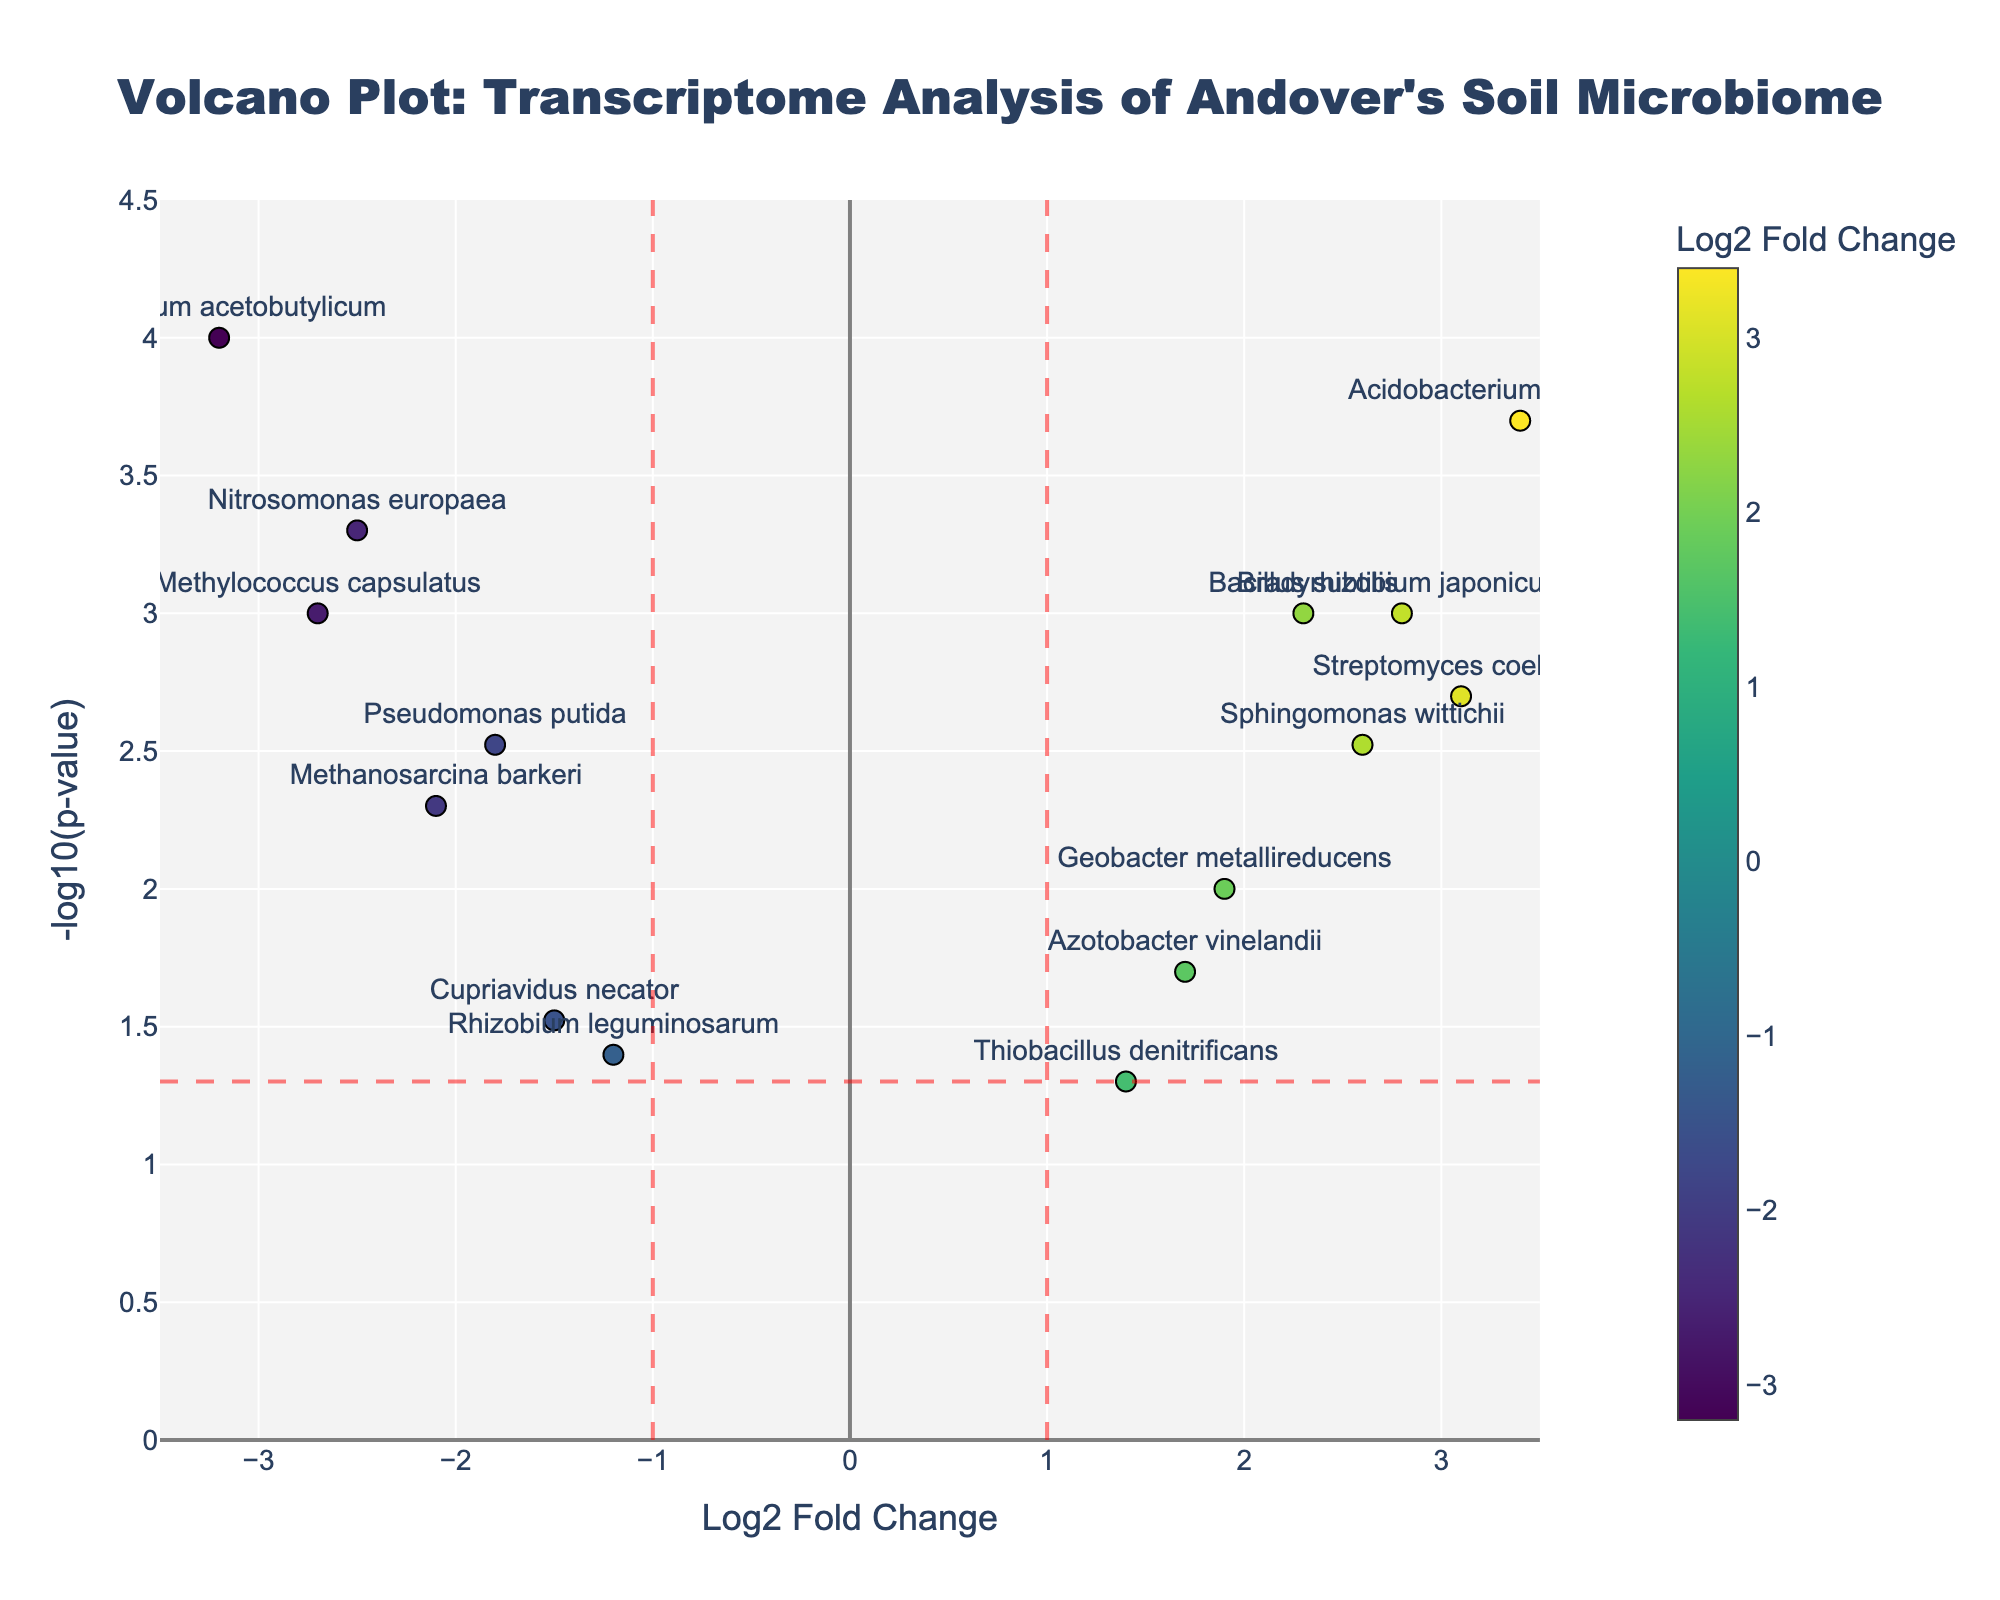What is the title of the plot? The title of the plot can be found at the top center of the figure. It reads "Volcano Plot: Transcriptome Analysis of Andover's Soil Microbiome".
Answer: Volcano Plot: Transcriptome Analysis of Andover's Soil Microbiome Which gene has the highest -log10(p-value)? The gene with the highest -log10(p-value) is found by looking for the point highest along the y-axis. This corresponds to the lowest p-value.
Answer: Clostridium acetobutylicum What are the Log2 Fold Change values where vertical lines are drawn? The vertical lines on the volcano plot are drawn at x = -1 and x = 1, which are typically used to indicate significant fold changes.
Answer: -1 and 1 What is the significance threshold indicated by the horizontal line? The horizontal line is drawn where -log10(p-value) = -log10(0.05). This threshold highlights genes with p-values less than 0.05.
Answer: 1.3 Name two genes that show up-regulation and have a p-value less than 0.05. Up-regulated genes have a positive Log2 Fold Change and appear above the significance threshold line (-log10(p-value) > 1.3). Two such genes are "Bacillus subtilis" and "Bradyrhizobium japonicum".
Answer: Bacillus subtilis, Bradyrhizobium japonicum Which gene has the largest Log2 Fold Change, and what is its -log10(p-value)? The gene with the largest Log2 Fold Change is identified by locating the farthest data point to the right along the x-axis. The corresponding gene is "Acidobacterium capsulatum". Its -log10(p-value) can be read from the y-axis, which is approximately 3.7.
Answer: Acidobacterium capsulatum, 3.7 Which gene has the smallest p-value, and what is its Log2 Fold Change? The gene with the smallest p-value has the highest value on the y-axis (-log10(p-value)). This gene is "Clostridium acetobutylicum", with a Log2 Fold Change of approximately -3.2.
Answer: Clostridium acetobutylicum, -3.2 How many genes are significantly down-regulated (p-value less than 0.05)? To determine the number of significantly down-regulated genes, count the points to the left of -1 (Log2 Fold Change < -1) and above the horizontal significance line (-log10(p-value) > 1.3). These genes are "Pseudomonas putida", "Nitrosomonas europaea", "Clostridium acetobutylicum", "Methanosarcina barkeri", and "Methylococcus capsulatus".
Answer: 5 Which gene with a Log2 Fold Change less than -2 shows the smallest p-value? Among the genes with Log2 Fold Change < -2, the one with the smallest p-value will be the highest on the y-axis. "Clostridium acetobutylicum" has the smallest p-value with a Log2 Fold Change of -3.2.
Answer: Clostridium acetobutylicum What is the range of -log10(p-value) displayed on the y-axis? The range of the y-axis can be observed by noting the minimum and maximum values along the y-axis. The axis ranges from 0 to 4.5.
Answer: 0 to 4.5 